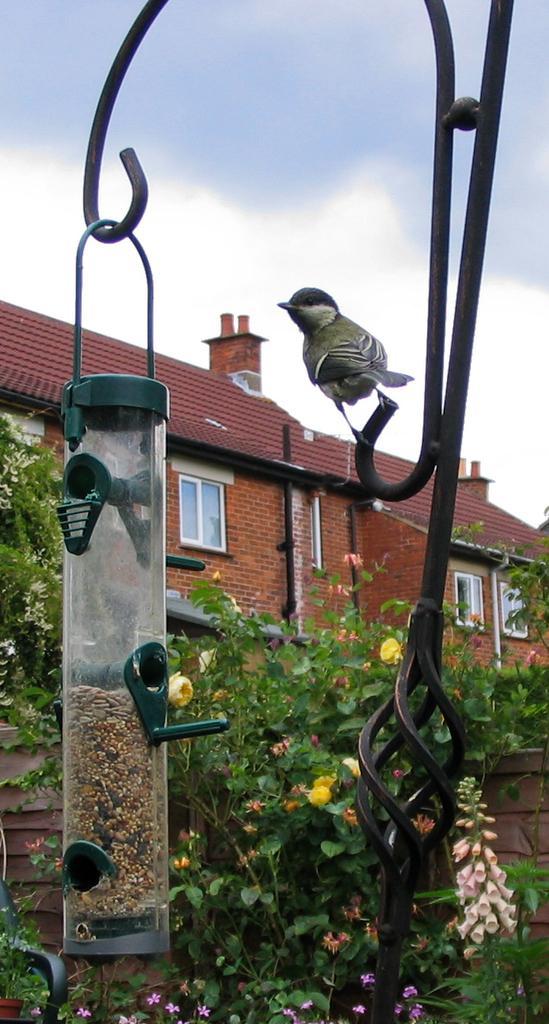Please provide a concise description of this image. In this image there is a bird feeder is hanging to a pole as we can see in the bottom of this image. There is one bird sitting on to this pole on the right side of this image. There are some plants with flowers in the background. There is a house in the middle of this image,and there is a sky on the top of this image. 